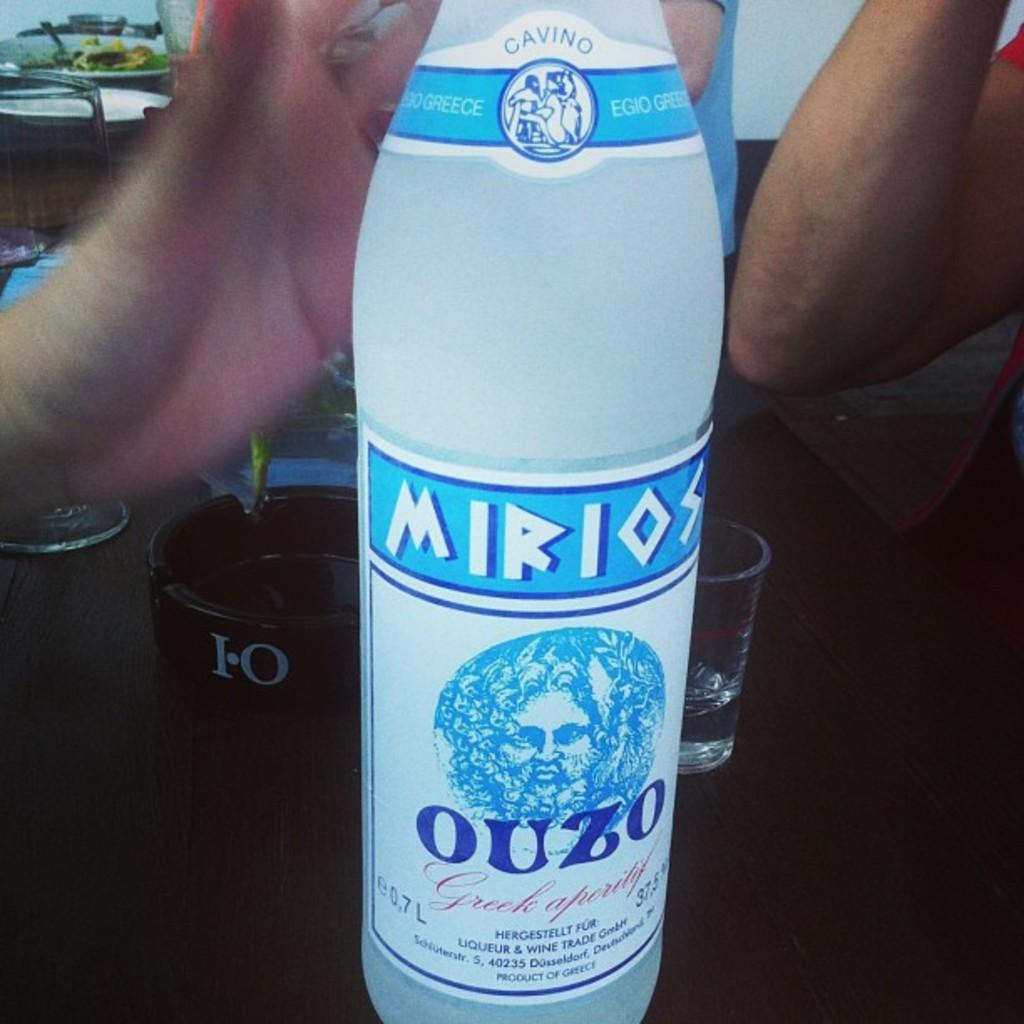Provide a one-sentence caption for the provided image. A bottle of Mirios Ouzo Greek liquor on a table top. 